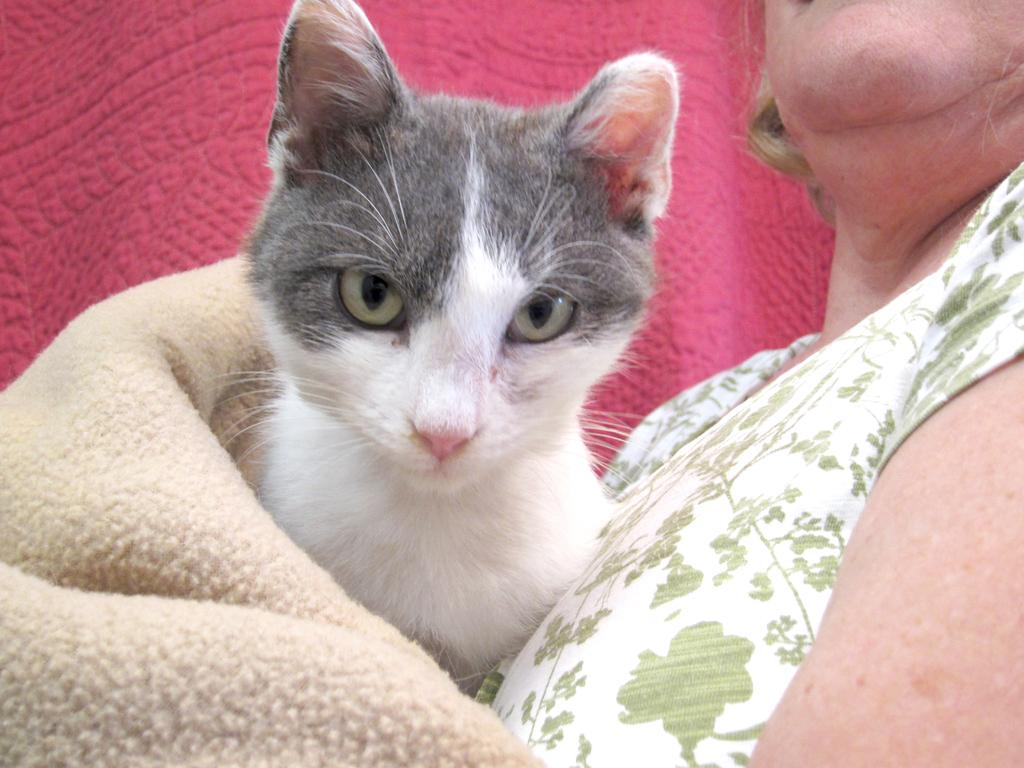Who is present in the image? There is a woman in the image. What animal is also present in the image? There is a cat in the image. What object can be seen in the image? There is a blanket in the image. What is the tendency of the beds in the image? There are no beds present in the image, so it's not possible to determine any tendencies. 